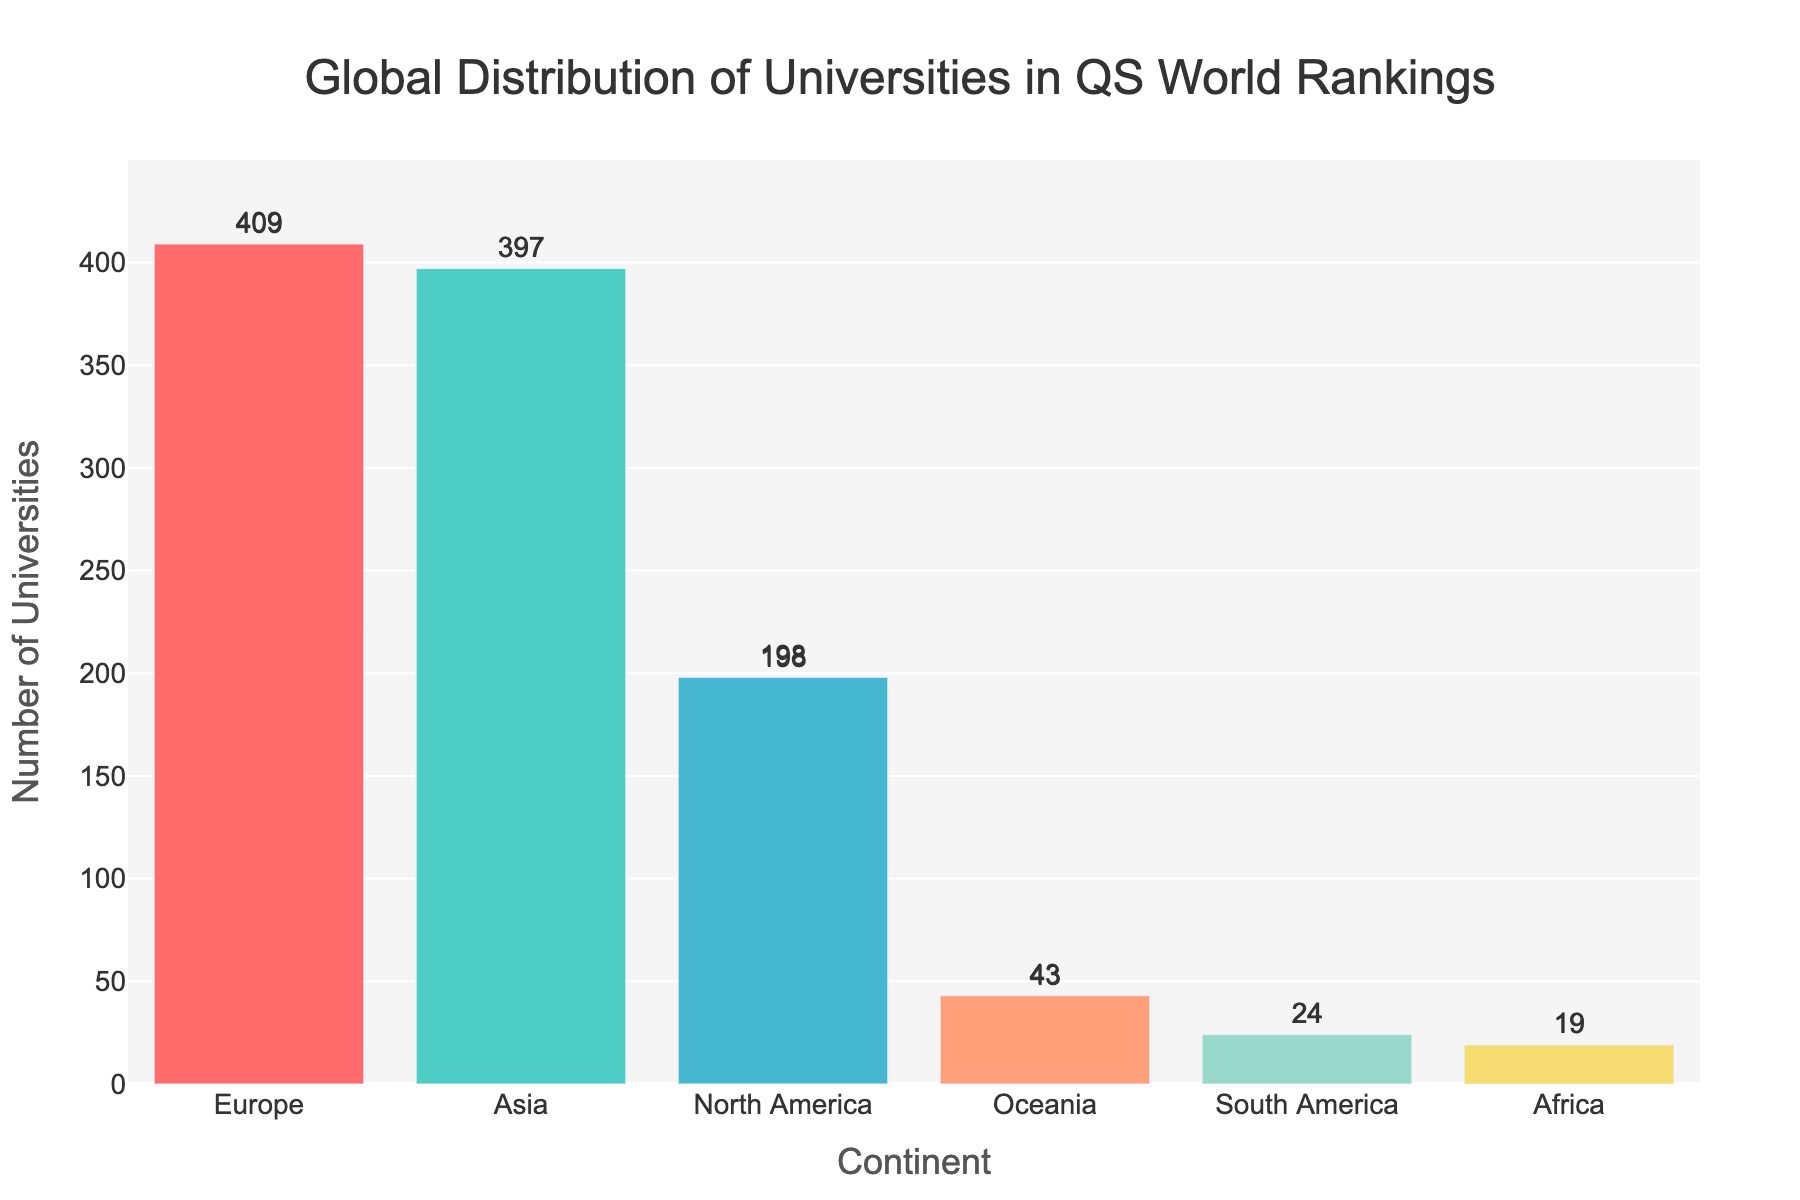Which continent has the highest number of universities in the QS World University Rankings? Europe has the highest number of universities in the QS World University Rankings. By looking at the bar chart, we can see that the bar for Europe is the tallest, which indicates it has the most universities among all listed continents.
Answer: Europe What is the total number of universities in Asia and North America combined? To find the total number of universities in Asia and North America, we need to add the values for these two continents. According to the chart, Asia has 397 universities, and North America has 198. So, the sum is 397 + 198 = 595.
Answer: 595 How many more universities does Europe have compared to Oceania? To find the difference in the number of universities between Europe and Oceania, subtract the number of universities in Oceania from the number of universities in Europe. Europe has 409 universities, while Oceania has 43 universities. So, the difference is 409 - 43 = 366.
Answer: 366 Which continent has the fewest universities, and how many does it have? Looking at the bar chart, the bar for Africa is the shortest, indicating that Africa has the fewest universities. The number of universities in Africa is 19.
Answer: Africa, 19 How many universities are there in continents with fewer than 100 universities combined? To find the number of universities in continents with fewer than 100 universities, sum the values for Oceania, South America, and Africa. Oceania has 43 universities, South America has 24, and Africa has 19. Therefore, the total is 43 + 24 + 19 = 86.
Answer: 86 What's the visual difference between the highest bar and the lowest bar in the chart? The highest bar in the chart represents Europe, while the lowest bar represents Africa. Visually, the difference is significant as the bar for Europe is much taller, indicating a much higher number of universities compared to Africa. This can be quantified as Europe has 409 universities, and Africa has 19, making the difference 409 - 19 = 390, visually represented by the height of the bars.
Answer: 390 Which two continents have almost the same number of universities? Europe and Asia have a similar number of universities. The bar for Europe is slightly taller than Asia, indicating Europe has 409 universities while Asia has 397 universities. The difference is minor compared to other continents.
Answer: Europe and Asia On average, how many universities are present per continent? To find the average number of universities per continent, sum the number of universities in all the continents and then divide by the number of continents. The total number of universities is 409 (Europe) + 397 (Asia) + 198 (North America) + 43 (Oceania) + 24 (South America) + 19 (Africa) = 1090. There are 6 continents listed, so the average is 1090 / 6 ≈ 181.67.
Answer: 181.67 How does the number of universities in South America compare to North America? North America has significantly more universities than South America. The chart shows North America with 198 universities and South America with 24 universities. The difference is 198 - 24 = 174.
Answer: North America has 174 more universities than South America 